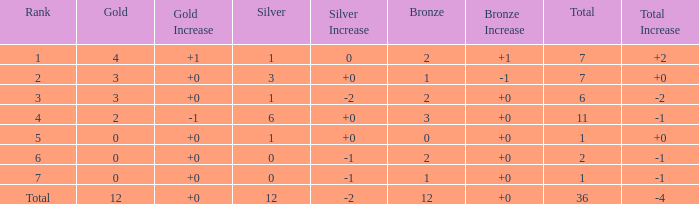What is the highest number of silver medals for a team with total less than 1? None. 